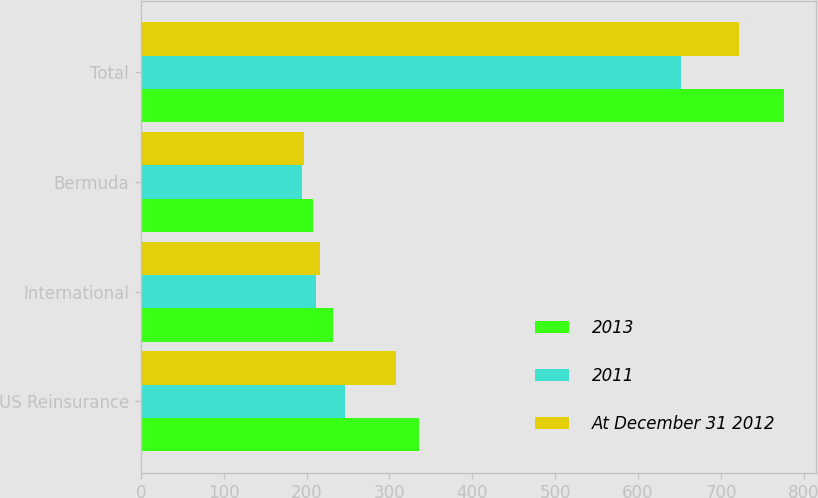<chart> <loc_0><loc_0><loc_500><loc_500><stacked_bar_chart><ecel><fcel>US Reinsurance<fcel>International<fcel>Bermuda<fcel>Total<nl><fcel>2013<fcel>336<fcel>231.5<fcel>207.8<fcel>775.6<nl><fcel>2011<fcel>246.6<fcel>211<fcel>194<fcel>651.6<nl><fcel>At December 31 2012<fcel>308.2<fcel>216.8<fcel>196.9<fcel>722<nl></chart> 